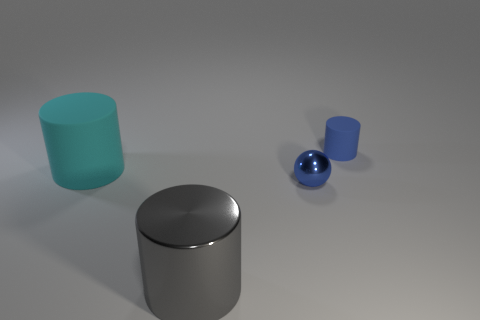There is a matte cylinder that is the same color as the tiny metal thing; what is its size?
Give a very brief answer. Small. Are there any cyan matte objects right of the blue object that is in front of the cylinder that is on the right side of the tiny blue metal sphere?
Offer a terse response. No. Are there any big gray cylinders behind the big shiny thing?
Ensure brevity in your answer.  No. There is a large thing that is in front of the small metallic object; what number of shiny cylinders are behind it?
Keep it short and to the point. 0. There is a sphere; is its size the same as the blue object behind the sphere?
Offer a terse response. Yes. Are there any metal objects of the same color as the large rubber cylinder?
Your response must be concise. No. There is another object that is the same material as the big cyan object; what size is it?
Give a very brief answer. Small. Does the cyan thing have the same material as the big gray object?
Ensure brevity in your answer.  No. What color is the thing behind the big thing behind the large thing in front of the cyan rubber cylinder?
Give a very brief answer. Blue. What is the shape of the small blue shiny object?
Offer a very short reply. Sphere. 